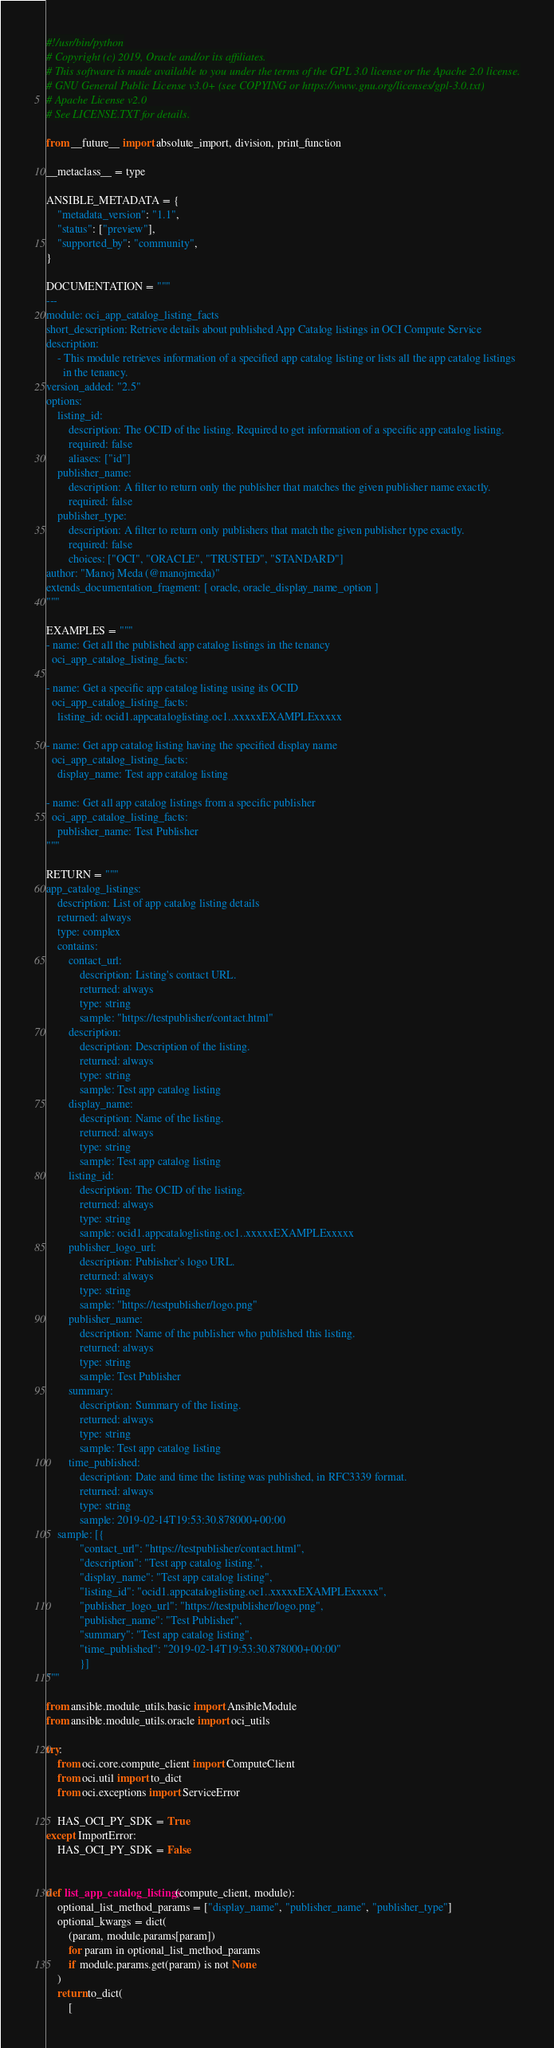Convert code to text. <code><loc_0><loc_0><loc_500><loc_500><_Python_>#!/usr/bin/python
# Copyright (c) 2019, Oracle and/or its affiliates.
# This software is made available to you under the terms of the GPL 3.0 license or the Apache 2.0 license.
# GNU General Public License v3.0+ (see COPYING or https://www.gnu.org/licenses/gpl-3.0.txt)
# Apache License v2.0
# See LICENSE.TXT for details.

from __future__ import absolute_import, division, print_function

__metaclass__ = type

ANSIBLE_METADATA = {
    "metadata_version": "1.1",
    "status": ["preview"],
    "supported_by": "community",
}

DOCUMENTATION = """
---
module: oci_app_catalog_listing_facts
short_description: Retrieve details about published App Catalog listings in OCI Compute Service
description:
    - This module retrieves information of a specified app catalog listing or lists all the app catalog listings
      in the tenancy.
version_added: "2.5"
options:
    listing_id:
        description: The OCID of the listing. Required to get information of a specific app catalog listing.
        required: false
        aliases: ["id"]
    publisher_name:
        description: A filter to return only the publisher that matches the given publisher name exactly.
        required: false
    publisher_type:
        description: A filter to return only publishers that match the given publisher type exactly.
        required: false
        choices: ["OCI", "ORACLE", "TRUSTED", "STANDARD"]
author: "Manoj Meda (@manojmeda)"
extends_documentation_fragment: [ oracle, oracle_display_name_option ]
"""

EXAMPLES = """
- name: Get all the published app catalog listings in the tenancy
  oci_app_catalog_listing_facts:

- name: Get a specific app catalog listing using its OCID
  oci_app_catalog_listing_facts:
    listing_id: ocid1.appcataloglisting.oc1..xxxxxEXAMPLExxxxx

- name: Get app catalog listing having the specified display name
  oci_app_catalog_listing_facts:
    display_name: Test app catalog listing

- name: Get all app catalog listings from a specific publisher
  oci_app_catalog_listing_facts:
    publisher_name: Test Publisher
"""

RETURN = """
app_catalog_listings:
    description: List of app catalog listing details
    returned: always
    type: complex
    contains:
        contact_url:
            description: Listing's contact URL.
            returned: always
            type: string
            sample: "https://testpublisher/contact.html"
        description:
            description: Description of the listing.
            returned: always
            type: string
            sample: Test app catalog listing
        display_name:
            description: Name of the listing.
            returned: always
            type: string
            sample: Test app catalog listing
        listing_id:
            description: The OCID of the listing.
            returned: always
            type: string
            sample: ocid1.appcataloglisting.oc1..xxxxxEXAMPLExxxxx
        publisher_logo_url:
            description: Publisher's logo URL.
            returned: always
            type: string
            sample: "https://testpublisher/logo.png"
        publisher_name:
            description: Name of the publisher who published this listing.
            returned: always
            type: string
            sample: Test Publisher
        summary:
            description: Summary of the listing.
            returned: always
            type: string
            sample: Test app catalog listing
        time_published:
            description: Date and time the listing was published, in RFC3339 format.
            returned: always
            type: string
            sample: 2019-02-14T19:53:30.878000+00:00
    sample: [{
            "contact_url": "https://testpublisher/contact.html",
            "description": "Test app catalog listing.",
            "display_name": "Test app catalog listing",
            "listing_id": "ocid1.appcataloglisting.oc1..xxxxxEXAMPLExxxxx",
            "publisher_logo_url": "https://testpublisher/logo.png",
            "publisher_name": "Test Publisher",
            "summary": "Test app catalog listing",
            "time_published": "2019-02-14T19:53:30.878000+00:00"
            }]
"""

from ansible.module_utils.basic import AnsibleModule
from ansible.module_utils.oracle import oci_utils

try:
    from oci.core.compute_client import ComputeClient
    from oci.util import to_dict
    from oci.exceptions import ServiceError

    HAS_OCI_PY_SDK = True
except ImportError:
    HAS_OCI_PY_SDK = False


def list_app_catalog_listings(compute_client, module):
    optional_list_method_params = ["display_name", "publisher_name", "publisher_type"]
    optional_kwargs = dict(
        (param, module.params[param])
        for param in optional_list_method_params
        if module.params.get(param) is not None
    )
    return to_dict(
        [</code> 